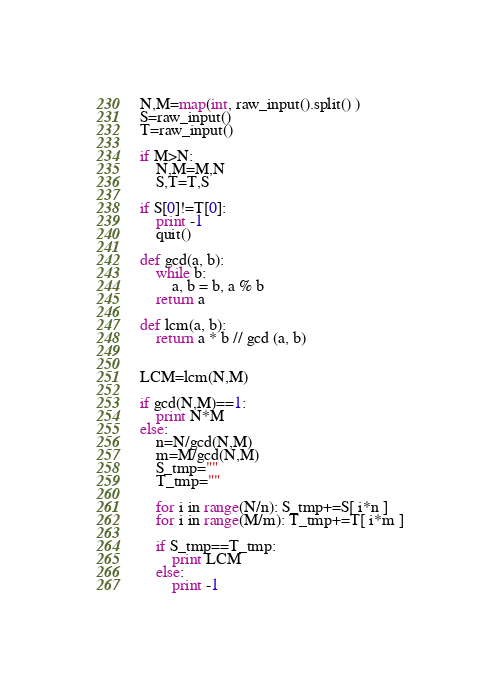<code> <loc_0><loc_0><loc_500><loc_500><_Python_>N,M=map(int, raw_input().split() )
S=raw_input()
T=raw_input()

if M>N:
	N,M=M,N
	S,T=T,S

if S[0]!=T[0]:
	print -1
	quit()

def gcd(a, b):
	while b:
		a, b = b, a % b
	return a

def lcm(a, b):
	return a * b // gcd (a, b)


LCM=lcm(N,M)

if gcd(N,M)==1:
	print N*M
else:
	n=N/gcd(N,M)
	m=M/gcd(N,M)
	S_tmp=""
	T_tmp=""

	for i in range(N/n): S_tmp+=S[ i*n ]
	for i in range(M/m): T_tmp+=T[ i*m ]

	if S_tmp==T_tmp:
		print LCM
	else:
		print -1


</code> 